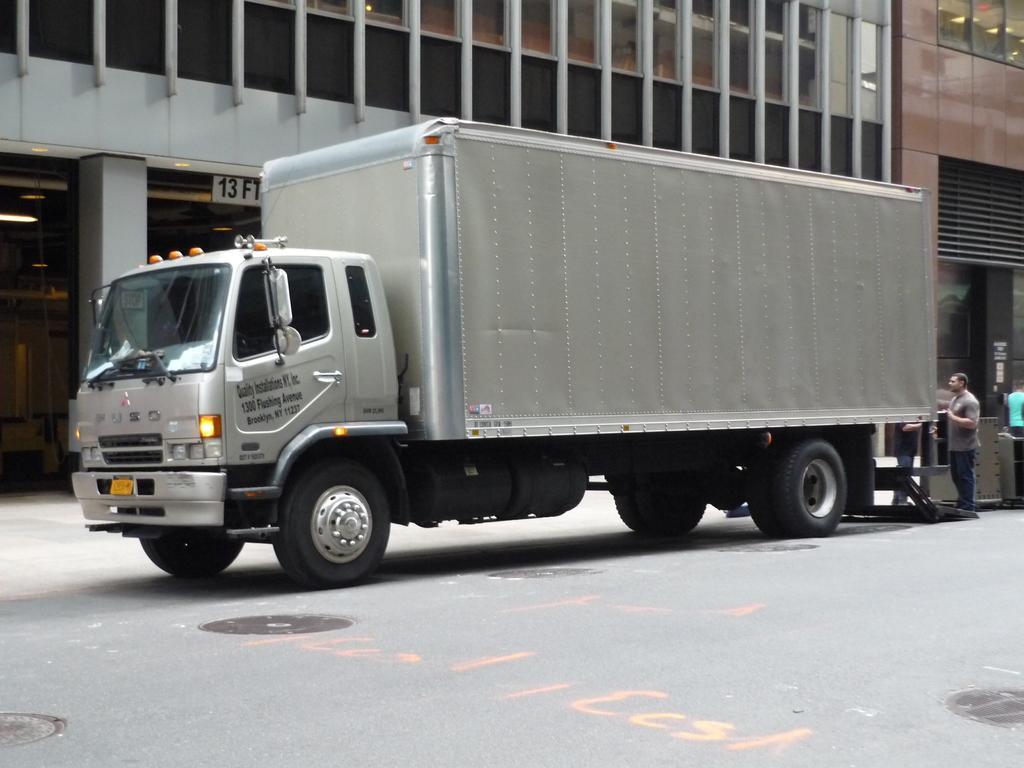How would you summarize this image in a sentence or two? In this image, in the middle there is a vehicle. On the right there are people. At the bottom there is a road. In the background there are buildings, windows, glasses, lights, board, pillars. 